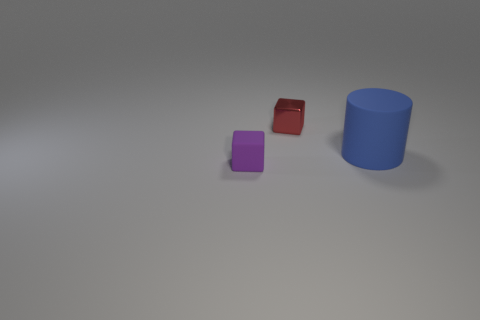Is the number of shiny things less than the number of tiny yellow things?
Offer a very short reply. No. What is the color of the small cube that is left of the tiny metallic thing?
Offer a very short reply. Purple. There is a small thing behind the object that is in front of the large object; what is its shape?
Offer a very short reply. Cube. Does the tiny red block have the same material as the tiny thing that is in front of the big object?
Ensure brevity in your answer.  No. What number of blue matte cylinders are the same size as the blue object?
Give a very brief answer. 0. Is the number of big matte objects that are in front of the purple block less than the number of brown metal cubes?
Keep it short and to the point. No. How many blue matte things are right of the rubber cylinder?
Give a very brief answer. 0. How big is the thing to the right of the block to the right of the thing in front of the blue thing?
Provide a short and direct response. Large. There is a red metallic object; does it have the same shape as the rubber object right of the shiny cube?
Provide a succinct answer. No. What size is the blue thing that is made of the same material as the purple object?
Keep it short and to the point. Large. 